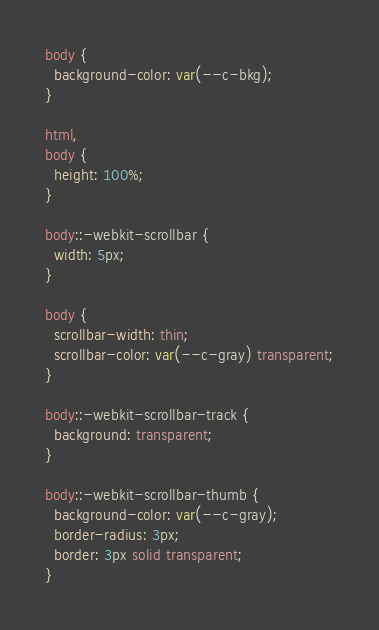Convert code to text. <code><loc_0><loc_0><loc_500><loc_500><_CSS_>body {
  background-color: var(--c-bkg);
}

html,
body {
  height: 100%;
}

body::-webkit-scrollbar {
  width: 5px;
}

body {
  scrollbar-width: thin;
  scrollbar-color: var(--c-gray) transparent;
}

body::-webkit-scrollbar-track {
  background: transparent;
}

body::-webkit-scrollbar-thumb {
  background-color: var(--c-gray);
  border-radius: 3px;
  border: 3px solid transparent;
}
</code> 